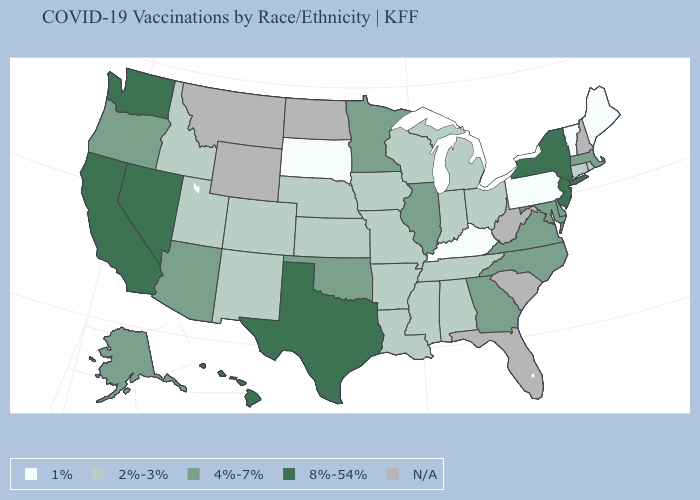Does the first symbol in the legend represent the smallest category?
Write a very short answer. Yes. Does the first symbol in the legend represent the smallest category?
Keep it brief. Yes. Does Hawaii have the highest value in the West?
Quick response, please. Yes. Name the states that have a value in the range 8%-54%?
Answer briefly. California, Hawaii, Nevada, New Jersey, New York, Texas, Washington. What is the value of Tennessee?
Quick response, please. 2%-3%. Which states have the highest value in the USA?
Quick response, please. California, Hawaii, Nevada, New Jersey, New York, Texas, Washington. What is the value of Kentucky?
Write a very short answer. 1%. What is the value of Alaska?
Keep it brief. 4%-7%. Name the states that have a value in the range 8%-54%?
Quick response, please. California, Hawaii, Nevada, New Jersey, New York, Texas, Washington. What is the lowest value in the MidWest?
Keep it brief. 1%. What is the value of Louisiana?
Keep it brief. 2%-3%. Among the states that border Vermont , does New York have the highest value?
Be succinct. Yes. Which states have the lowest value in the USA?
Answer briefly. Kentucky, Maine, Pennsylvania, South Dakota, Vermont. Name the states that have a value in the range 2%-3%?
Answer briefly. Alabama, Arkansas, Colorado, Connecticut, Idaho, Indiana, Iowa, Kansas, Louisiana, Michigan, Mississippi, Missouri, Nebraska, New Mexico, Ohio, Rhode Island, Tennessee, Utah, Wisconsin. Does New Jersey have the highest value in the Northeast?
Write a very short answer. Yes. 